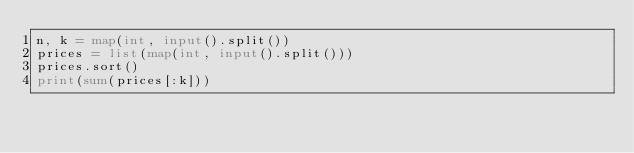<code> <loc_0><loc_0><loc_500><loc_500><_Python_>n, k = map(int, input().split())
prices = list(map(int, input().split()))
prices.sort()
print(sum(prices[:k]))
</code> 